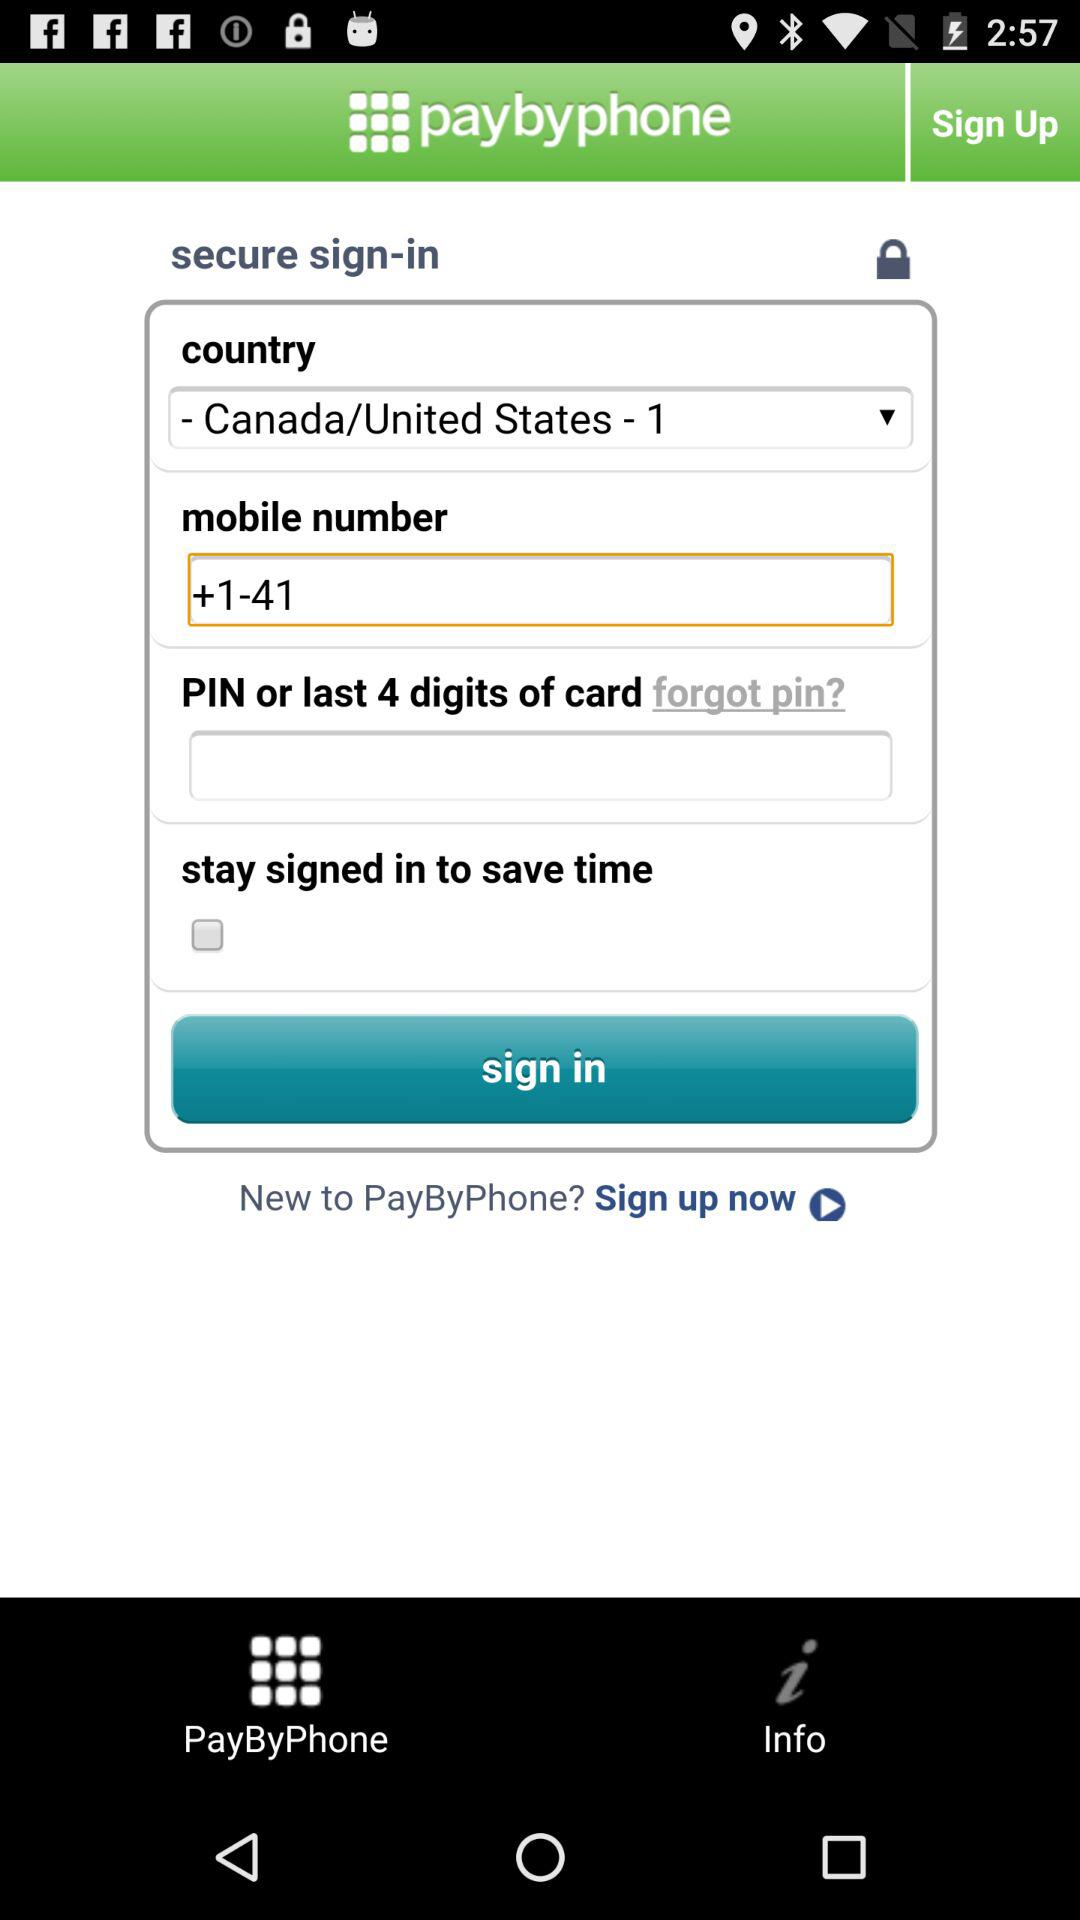What is the country code? The country code is +1. 